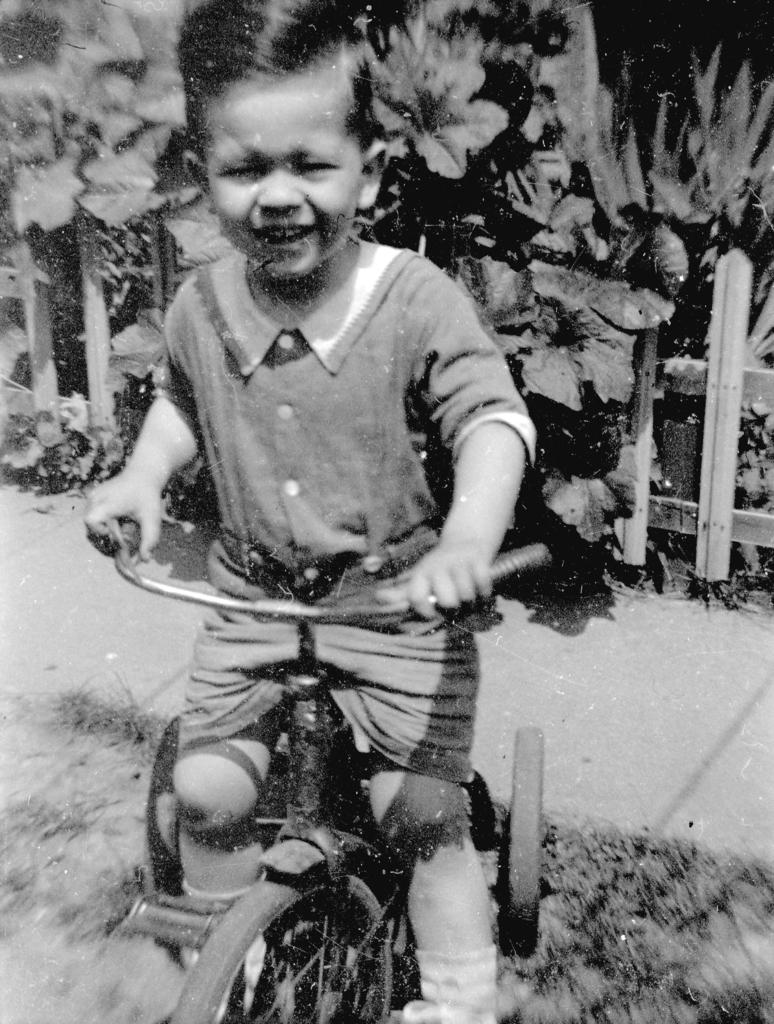What is the color scheme of the image? The image is black and white. What is the main subject of the image? There is a kid in the image. What is the kid doing in the image? The kid is sitting on a cycle. What can be seen behind the kid? There is a fence behind the kid, and plants are visible behind the fence. How many eggs are being attacked by the hat in the image? There are no eggs or hats present in the image. 